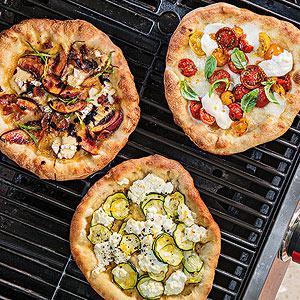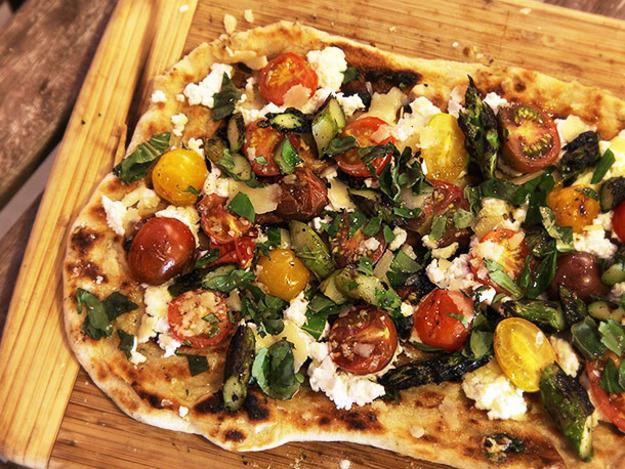The first image is the image on the left, the second image is the image on the right. Examine the images to the left and right. Is the description "One image shows multiple round pizzas on a metal grating." accurate? Answer yes or no. Yes. The first image is the image on the left, the second image is the image on the right. For the images displayed, is the sentence "Several pizzas sit on a rack in one of the images." factually correct? Answer yes or no. Yes. 